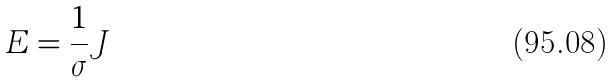<formula> <loc_0><loc_0><loc_500><loc_500>E = \frac { 1 } { \sigma } J</formula> 